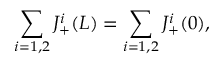Convert formula to latex. <formula><loc_0><loc_0><loc_500><loc_500>\sum _ { i = 1 , 2 } J _ { + } ^ { i } ( L ) = \sum _ { i = 1 , 2 } J _ { + } ^ { i } ( 0 ) ,</formula> 